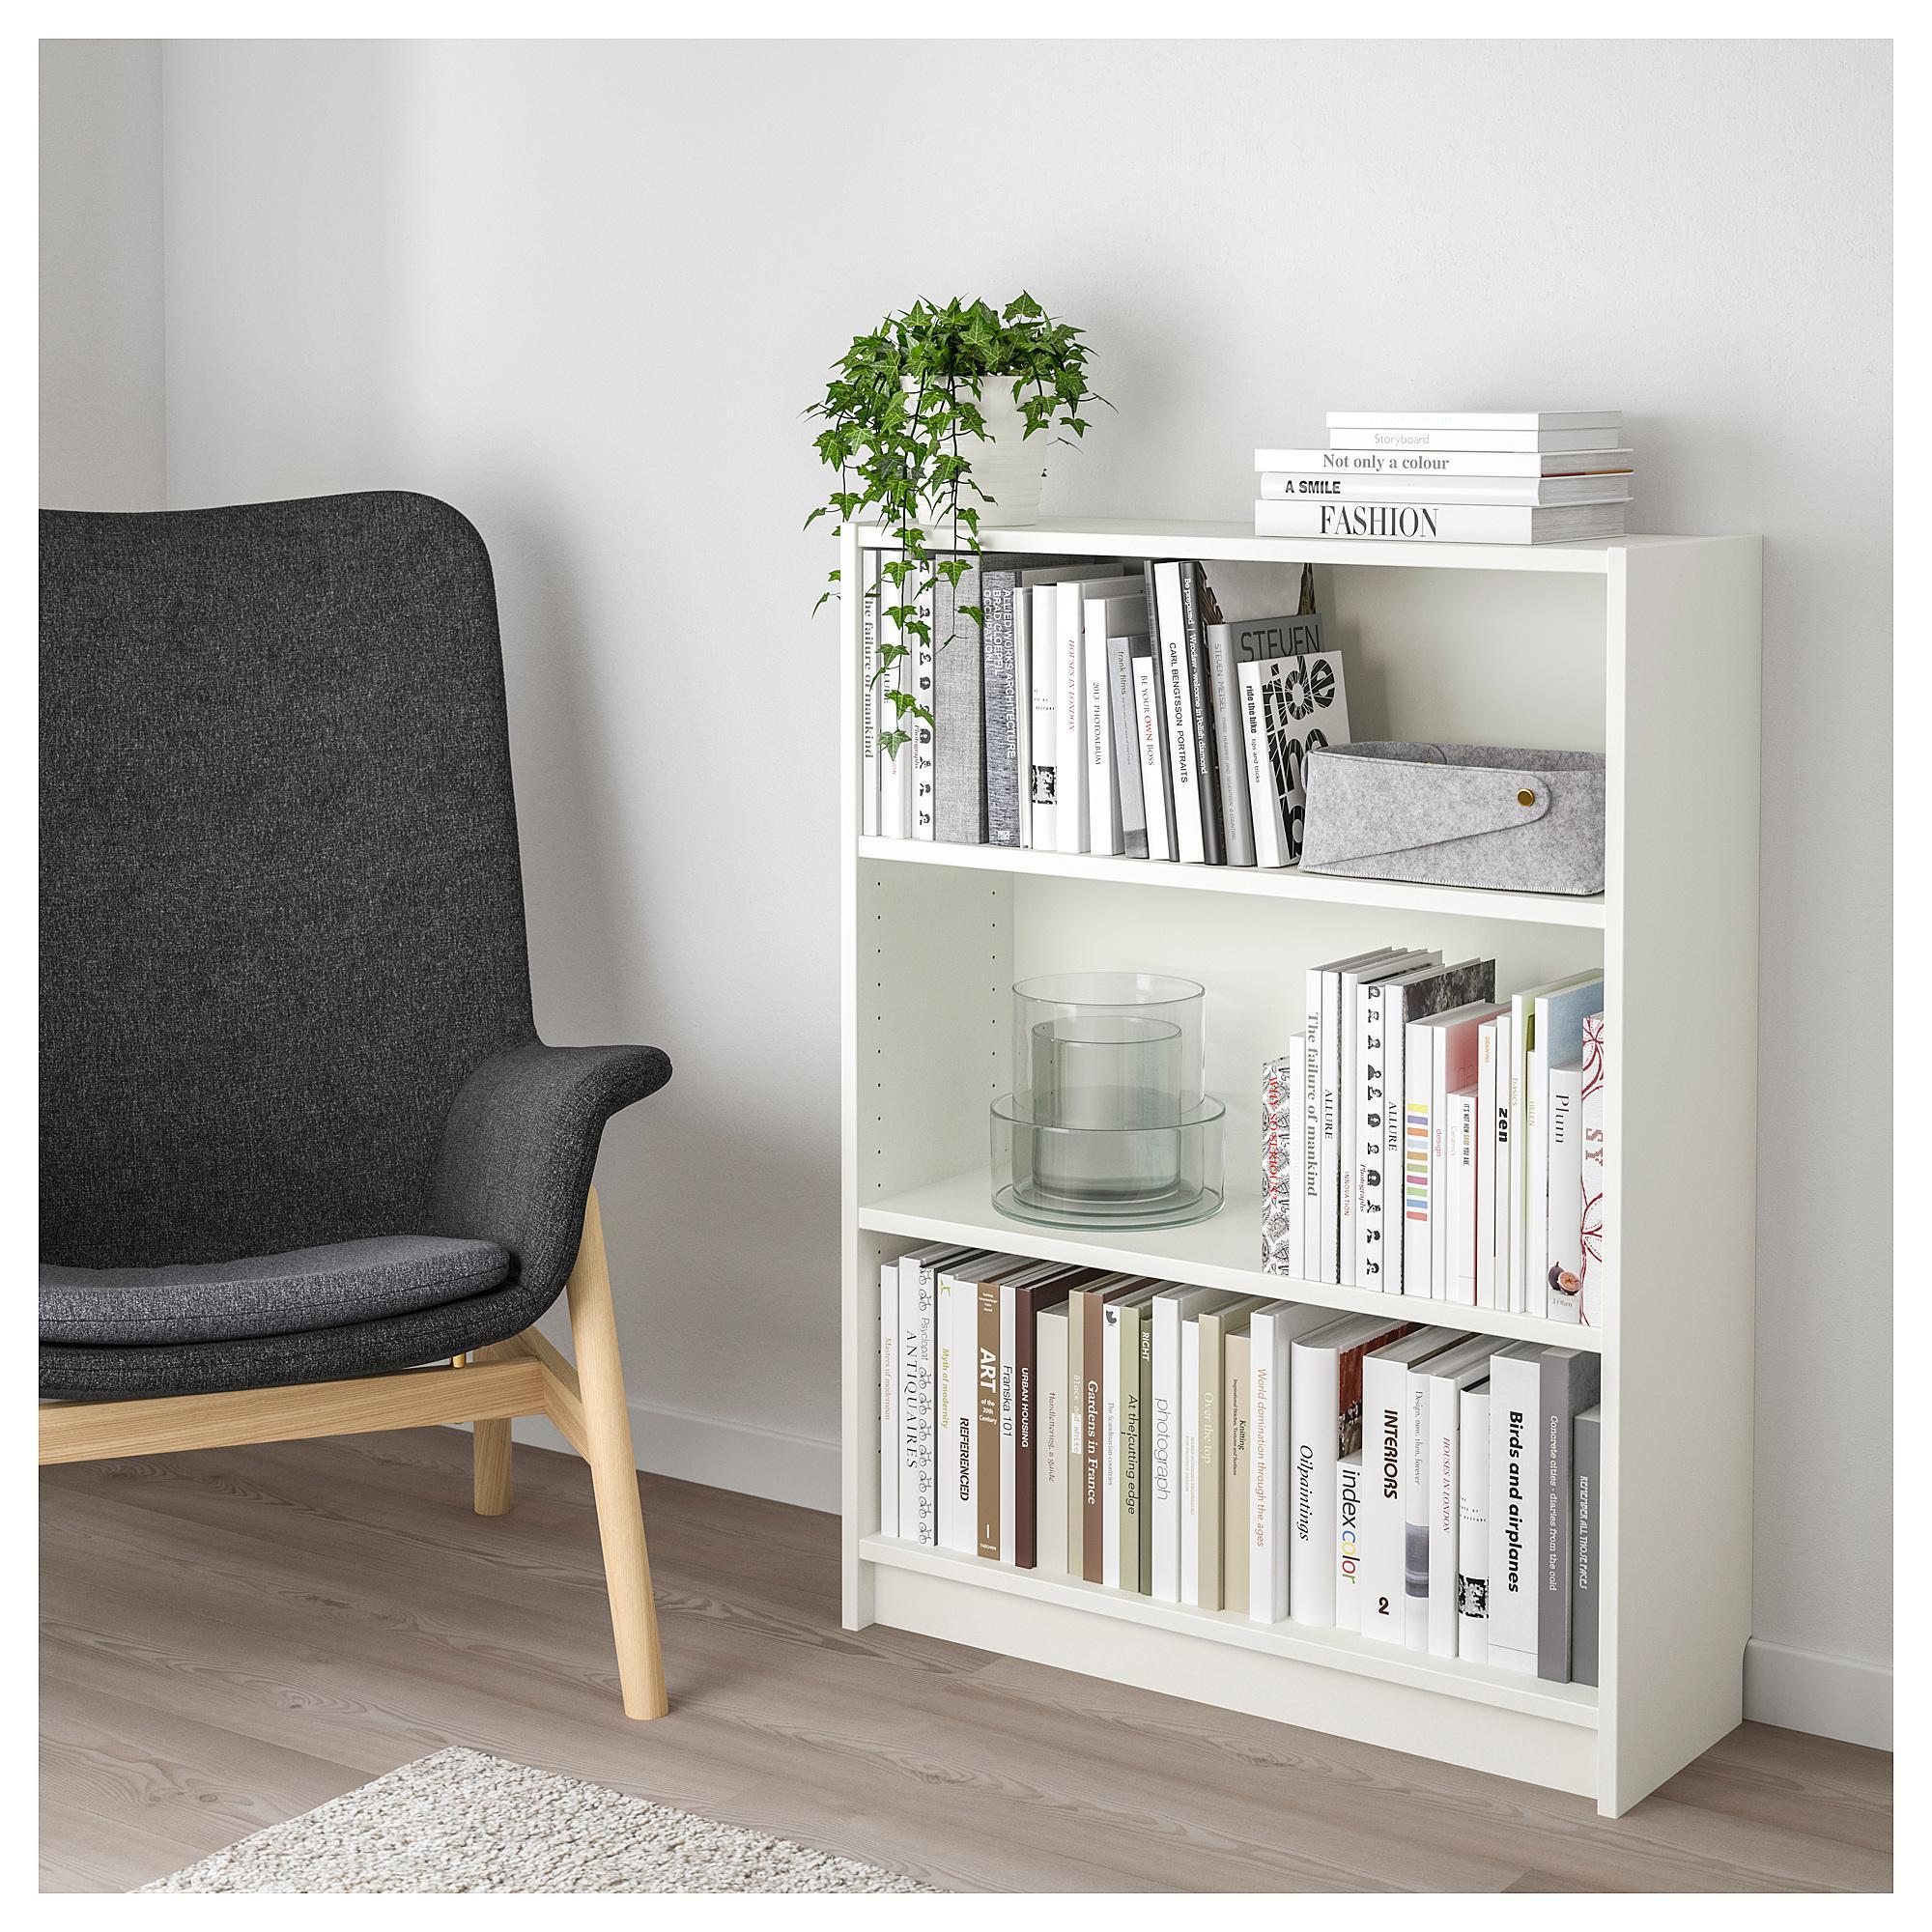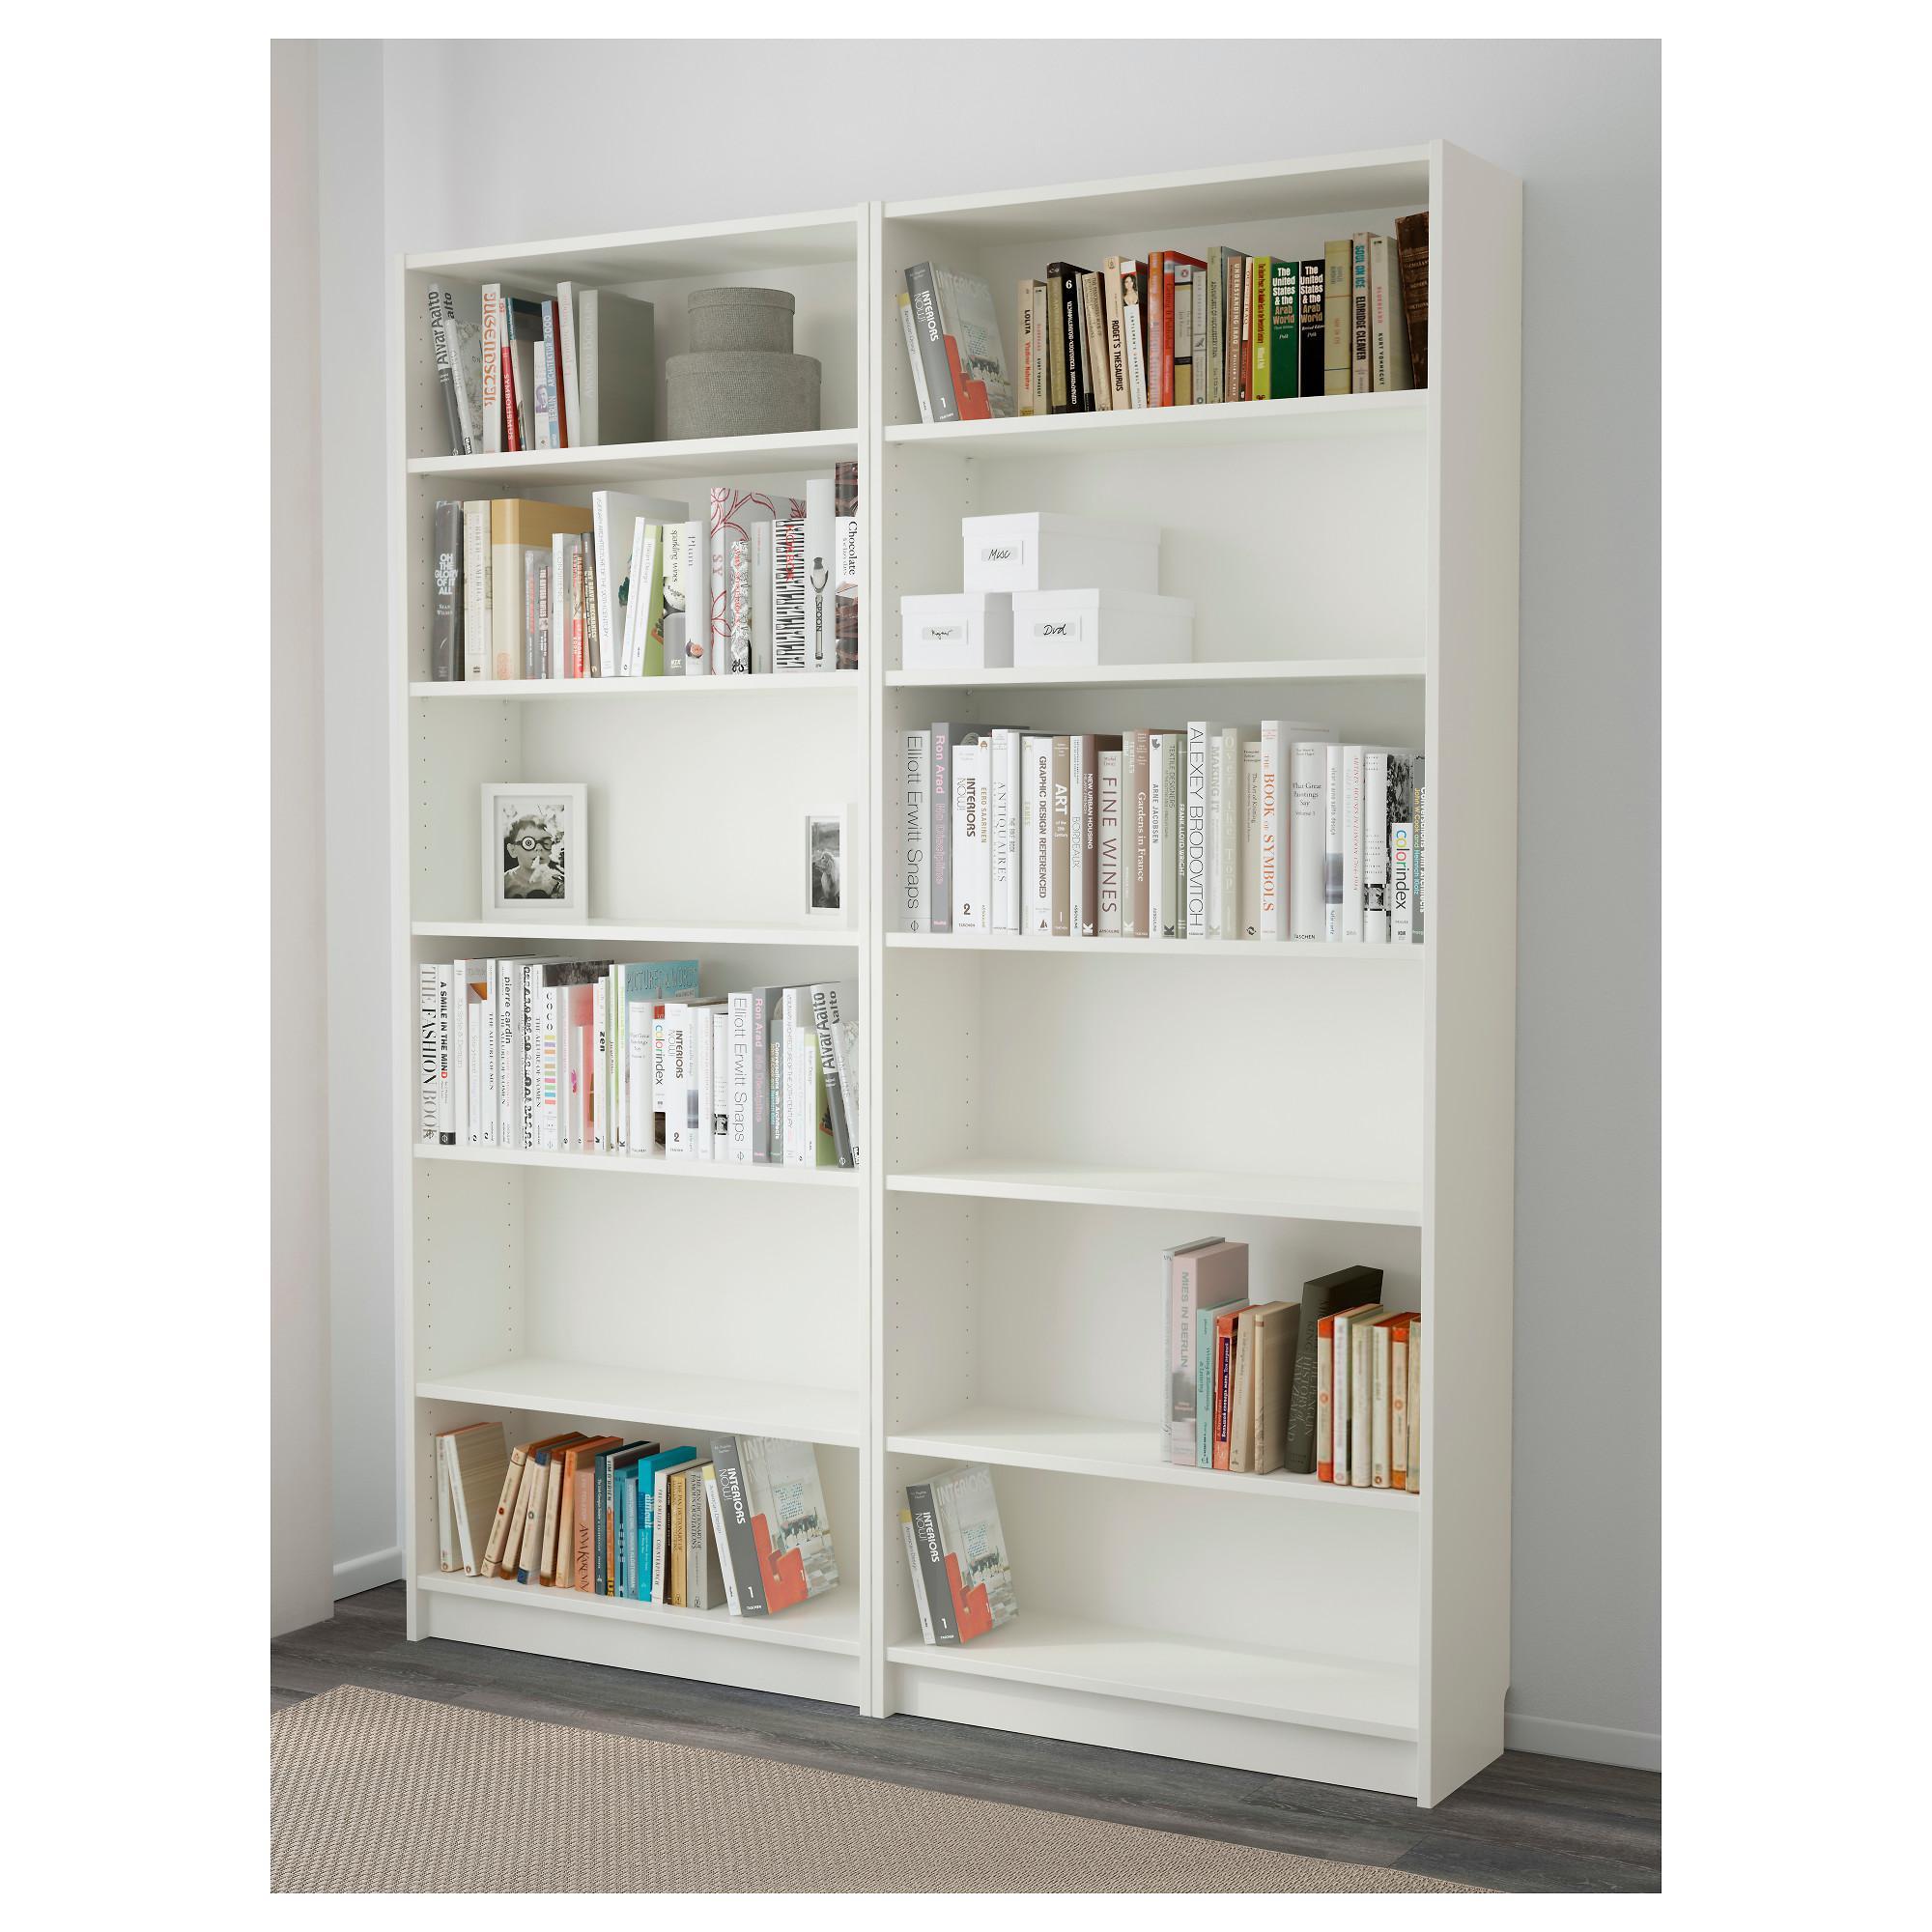The first image is the image on the left, the second image is the image on the right. Evaluate the accuracy of this statement regarding the images: "At least one of the images shows an empty bookcase.". Is it true? Answer yes or no. No. 